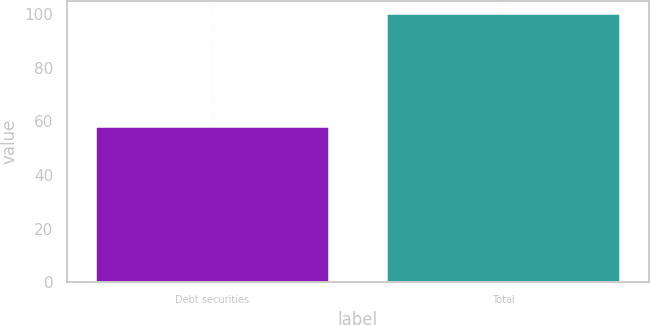<chart> <loc_0><loc_0><loc_500><loc_500><bar_chart><fcel>Debt securities<fcel>Total<nl><fcel>58<fcel>100<nl></chart> 